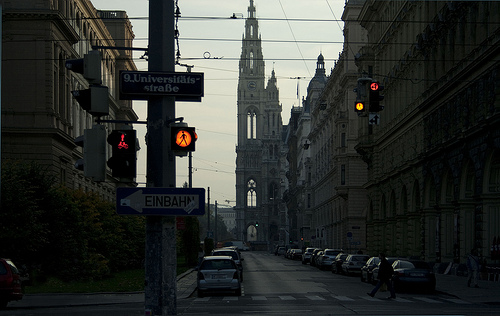What time of day does it appear to be in this image? The image seems to capture either early morning or late evening, as indicated by the soft, dim light in the sky, contrasting with the street lights that are still on. 